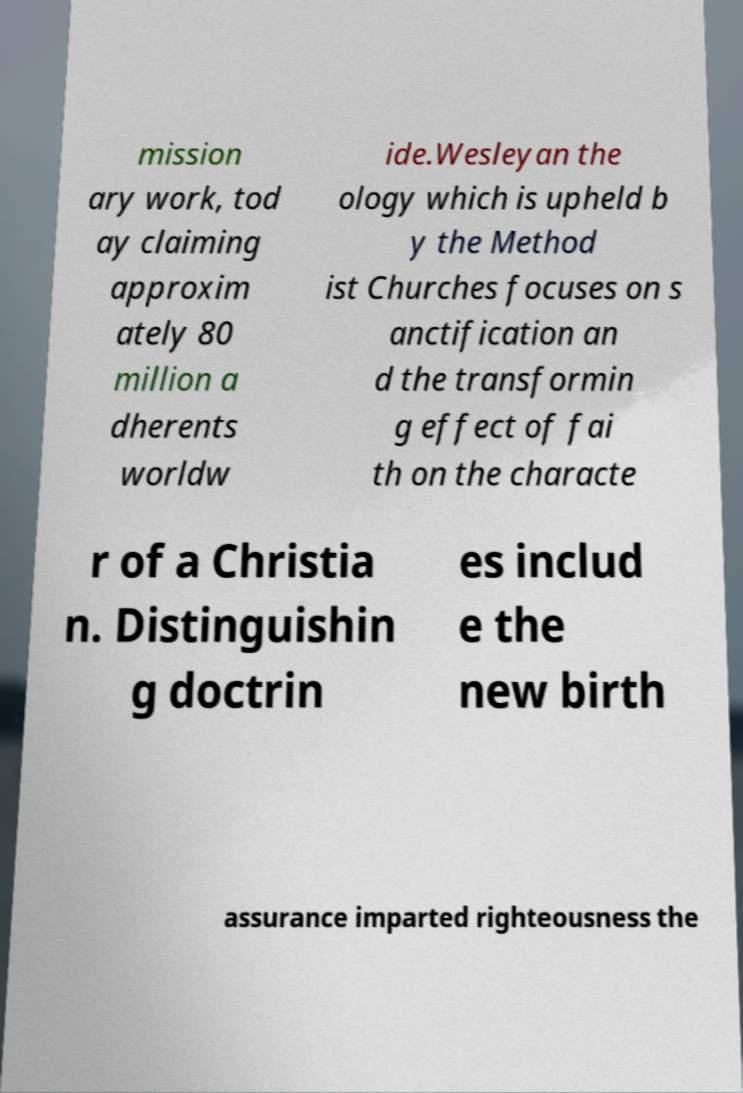Please read and relay the text visible in this image. What does it say? mission ary work, tod ay claiming approxim ately 80 million a dherents worldw ide.Wesleyan the ology which is upheld b y the Method ist Churches focuses on s anctification an d the transformin g effect of fai th on the characte r of a Christia n. Distinguishin g doctrin es includ e the new birth assurance imparted righteousness the 